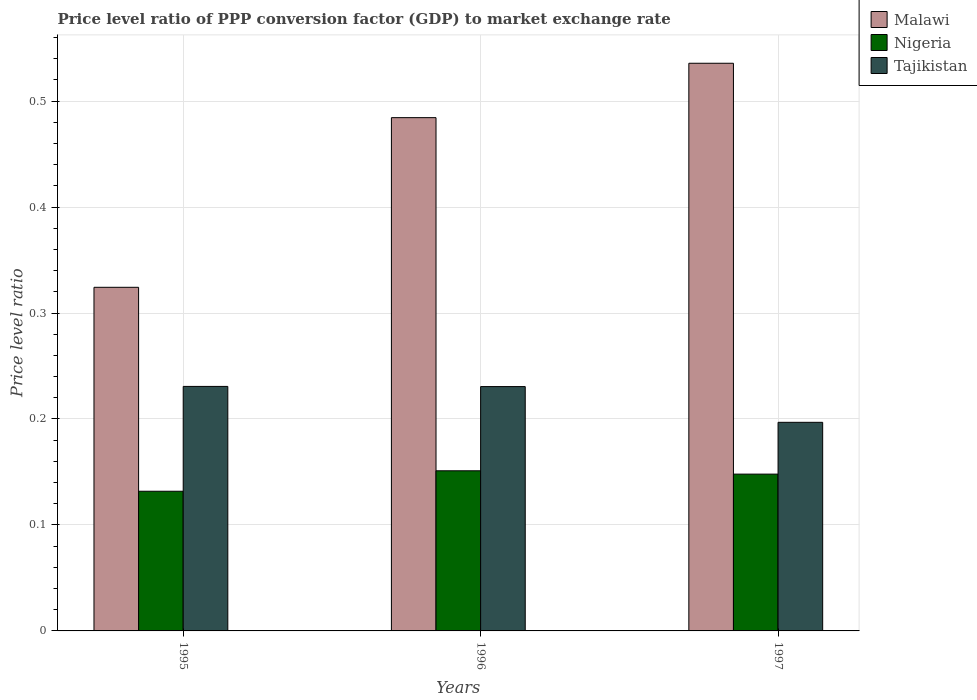How many groups of bars are there?
Give a very brief answer. 3. Are the number of bars per tick equal to the number of legend labels?
Provide a succinct answer. Yes. Are the number of bars on each tick of the X-axis equal?
Provide a short and direct response. Yes. How many bars are there on the 3rd tick from the right?
Your response must be concise. 3. What is the price level ratio in Nigeria in 1996?
Your response must be concise. 0.15. Across all years, what is the maximum price level ratio in Malawi?
Provide a succinct answer. 0.54. Across all years, what is the minimum price level ratio in Tajikistan?
Provide a short and direct response. 0.2. In which year was the price level ratio in Malawi minimum?
Give a very brief answer. 1995. What is the total price level ratio in Malawi in the graph?
Provide a succinct answer. 1.34. What is the difference between the price level ratio in Malawi in 1995 and that in 1997?
Make the answer very short. -0.21. What is the difference between the price level ratio in Tajikistan in 1996 and the price level ratio in Nigeria in 1995?
Provide a succinct answer. 0.1. What is the average price level ratio in Malawi per year?
Provide a succinct answer. 0.45. In the year 1996, what is the difference between the price level ratio in Tajikistan and price level ratio in Nigeria?
Offer a terse response. 0.08. What is the ratio of the price level ratio in Malawi in 1996 to that in 1997?
Keep it short and to the point. 0.9. Is the price level ratio in Nigeria in 1995 less than that in 1997?
Ensure brevity in your answer.  Yes. What is the difference between the highest and the second highest price level ratio in Tajikistan?
Provide a succinct answer. 0. What is the difference between the highest and the lowest price level ratio in Malawi?
Make the answer very short. 0.21. In how many years, is the price level ratio in Nigeria greater than the average price level ratio in Nigeria taken over all years?
Offer a very short reply. 2. What does the 1st bar from the left in 1997 represents?
Offer a terse response. Malawi. What does the 1st bar from the right in 1995 represents?
Offer a terse response. Tajikistan. Is it the case that in every year, the sum of the price level ratio in Nigeria and price level ratio in Malawi is greater than the price level ratio in Tajikistan?
Make the answer very short. Yes. How many bars are there?
Your answer should be very brief. 9. Are all the bars in the graph horizontal?
Your answer should be very brief. No. What is the difference between two consecutive major ticks on the Y-axis?
Give a very brief answer. 0.1. Does the graph contain any zero values?
Provide a succinct answer. No. How many legend labels are there?
Provide a succinct answer. 3. How are the legend labels stacked?
Ensure brevity in your answer.  Vertical. What is the title of the graph?
Provide a succinct answer. Price level ratio of PPP conversion factor (GDP) to market exchange rate. Does "Ghana" appear as one of the legend labels in the graph?
Ensure brevity in your answer.  No. What is the label or title of the Y-axis?
Your response must be concise. Price level ratio. What is the Price level ratio of Malawi in 1995?
Make the answer very short. 0.32. What is the Price level ratio of Nigeria in 1995?
Your answer should be compact. 0.13. What is the Price level ratio of Tajikistan in 1995?
Make the answer very short. 0.23. What is the Price level ratio in Malawi in 1996?
Your answer should be very brief. 0.48. What is the Price level ratio of Nigeria in 1996?
Give a very brief answer. 0.15. What is the Price level ratio in Tajikistan in 1996?
Your response must be concise. 0.23. What is the Price level ratio in Malawi in 1997?
Your answer should be compact. 0.54. What is the Price level ratio in Nigeria in 1997?
Your response must be concise. 0.15. What is the Price level ratio of Tajikistan in 1997?
Make the answer very short. 0.2. Across all years, what is the maximum Price level ratio of Malawi?
Your response must be concise. 0.54. Across all years, what is the maximum Price level ratio in Nigeria?
Offer a terse response. 0.15. Across all years, what is the maximum Price level ratio in Tajikistan?
Make the answer very short. 0.23. Across all years, what is the minimum Price level ratio in Malawi?
Make the answer very short. 0.32. Across all years, what is the minimum Price level ratio in Nigeria?
Keep it short and to the point. 0.13. Across all years, what is the minimum Price level ratio of Tajikistan?
Offer a terse response. 0.2. What is the total Price level ratio in Malawi in the graph?
Your answer should be very brief. 1.34. What is the total Price level ratio in Nigeria in the graph?
Offer a very short reply. 0.43. What is the total Price level ratio of Tajikistan in the graph?
Your answer should be very brief. 0.66. What is the difference between the Price level ratio in Malawi in 1995 and that in 1996?
Provide a succinct answer. -0.16. What is the difference between the Price level ratio of Nigeria in 1995 and that in 1996?
Give a very brief answer. -0.02. What is the difference between the Price level ratio of Malawi in 1995 and that in 1997?
Ensure brevity in your answer.  -0.21. What is the difference between the Price level ratio in Nigeria in 1995 and that in 1997?
Offer a terse response. -0.02. What is the difference between the Price level ratio in Tajikistan in 1995 and that in 1997?
Your answer should be very brief. 0.03. What is the difference between the Price level ratio of Malawi in 1996 and that in 1997?
Give a very brief answer. -0.05. What is the difference between the Price level ratio of Nigeria in 1996 and that in 1997?
Your answer should be very brief. 0. What is the difference between the Price level ratio in Tajikistan in 1996 and that in 1997?
Your answer should be very brief. 0.03. What is the difference between the Price level ratio of Malawi in 1995 and the Price level ratio of Nigeria in 1996?
Keep it short and to the point. 0.17. What is the difference between the Price level ratio in Malawi in 1995 and the Price level ratio in Tajikistan in 1996?
Ensure brevity in your answer.  0.09. What is the difference between the Price level ratio of Nigeria in 1995 and the Price level ratio of Tajikistan in 1996?
Keep it short and to the point. -0.1. What is the difference between the Price level ratio in Malawi in 1995 and the Price level ratio in Nigeria in 1997?
Provide a succinct answer. 0.18. What is the difference between the Price level ratio in Malawi in 1995 and the Price level ratio in Tajikistan in 1997?
Your answer should be compact. 0.13. What is the difference between the Price level ratio in Nigeria in 1995 and the Price level ratio in Tajikistan in 1997?
Your answer should be very brief. -0.07. What is the difference between the Price level ratio in Malawi in 1996 and the Price level ratio in Nigeria in 1997?
Offer a very short reply. 0.34. What is the difference between the Price level ratio in Malawi in 1996 and the Price level ratio in Tajikistan in 1997?
Give a very brief answer. 0.29. What is the difference between the Price level ratio of Nigeria in 1996 and the Price level ratio of Tajikistan in 1997?
Your answer should be compact. -0.05. What is the average Price level ratio of Malawi per year?
Make the answer very short. 0.45. What is the average Price level ratio in Nigeria per year?
Your answer should be very brief. 0.14. What is the average Price level ratio of Tajikistan per year?
Make the answer very short. 0.22. In the year 1995, what is the difference between the Price level ratio in Malawi and Price level ratio in Nigeria?
Your answer should be very brief. 0.19. In the year 1995, what is the difference between the Price level ratio in Malawi and Price level ratio in Tajikistan?
Offer a very short reply. 0.09. In the year 1995, what is the difference between the Price level ratio in Nigeria and Price level ratio in Tajikistan?
Your answer should be very brief. -0.1. In the year 1996, what is the difference between the Price level ratio of Malawi and Price level ratio of Nigeria?
Ensure brevity in your answer.  0.33. In the year 1996, what is the difference between the Price level ratio in Malawi and Price level ratio in Tajikistan?
Make the answer very short. 0.25. In the year 1996, what is the difference between the Price level ratio in Nigeria and Price level ratio in Tajikistan?
Offer a very short reply. -0.08. In the year 1997, what is the difference between the Price level ratio in Malawi and Price level ratio in Nigeria?
Offer a very short reply. 0.39. In the year 1997, what is the difference between the Price level ratio of Malawi and Price level ratio of Tajikistan?
Your answer should be compact. 0.34. In the year 1997, what is the difference between the Price level ratio of Nigeria and Price level ratio of Tajikistan?
Your response must be concise. -0.05. What is the ratio of the Price level ratio of Malawi in 1995 to that in 1996?
Your answer should be compact. 0.67. What is the ratio of the Price level ratio of Nigeria in 1995 to that in 1996?
Ensure brevity in your answer.  0.87. What is the ratio of the Price level ratio of Tajikistan in 1995 to that in 1996?
Offer a very short reply. 1. What is the ratio of the Price level ratio of Malawi in 1995 to that in 1997?
Keep it short and to the point. 0.61. What is the ratio of the Price level ratio in Nigeria in 1995 to that in 1997?
Your answer should be compact. 0.89. What is the ratio of the Price level ratio in Tajikistan in 1995 to that in 1997?
Give a very brief answer. 1.17. What is the ratio of the Price level ratio of Malawi in 1996 to that in 1997?
Provide a succinct answer. 0.9. What is the ratio of the Price level ratio of Nigeria in 1996 to that in 1997?
Make the answer very short. 1.02. What is the ratio of the Price level ratio of Tajikistan in 1996 to that in 1997?
Your answer should be compact. 1.17. What is the difference between the highest and the second highest Price level ratio in Malawi?
Provide a short and direct response. 0.05. What is the difference between the highest and the second highest Price level ratio of Nigeria?
Offer a terse response. 0. What is the difference between the highest and the lowest Price level ratio of Malawi?
Offer a terse response. 0.21. What is the difference between the highest and the lowest Price level ratio of Nigeria?
Make the answer very short. 0.02. What is the difference between the highest and the lowest Price level ratio in Tajikistan?
Offer a very short reply. 0.03. 